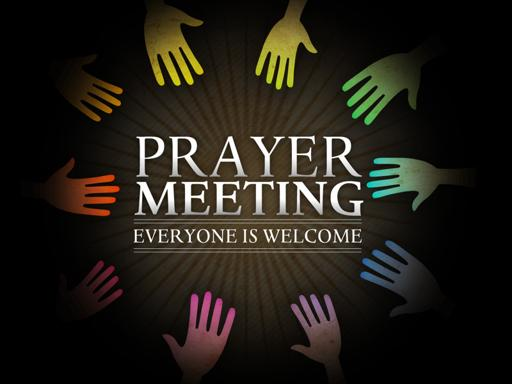What do the different colors of the hands signify in this context? The variety of colors used for the hands in the image likely symbolizes diversity and inclusivity, reflecting that the prayer meeting welcomes people from diverse backgrounds and cultures, and that it celebrates this diversity as a strength of the community. 